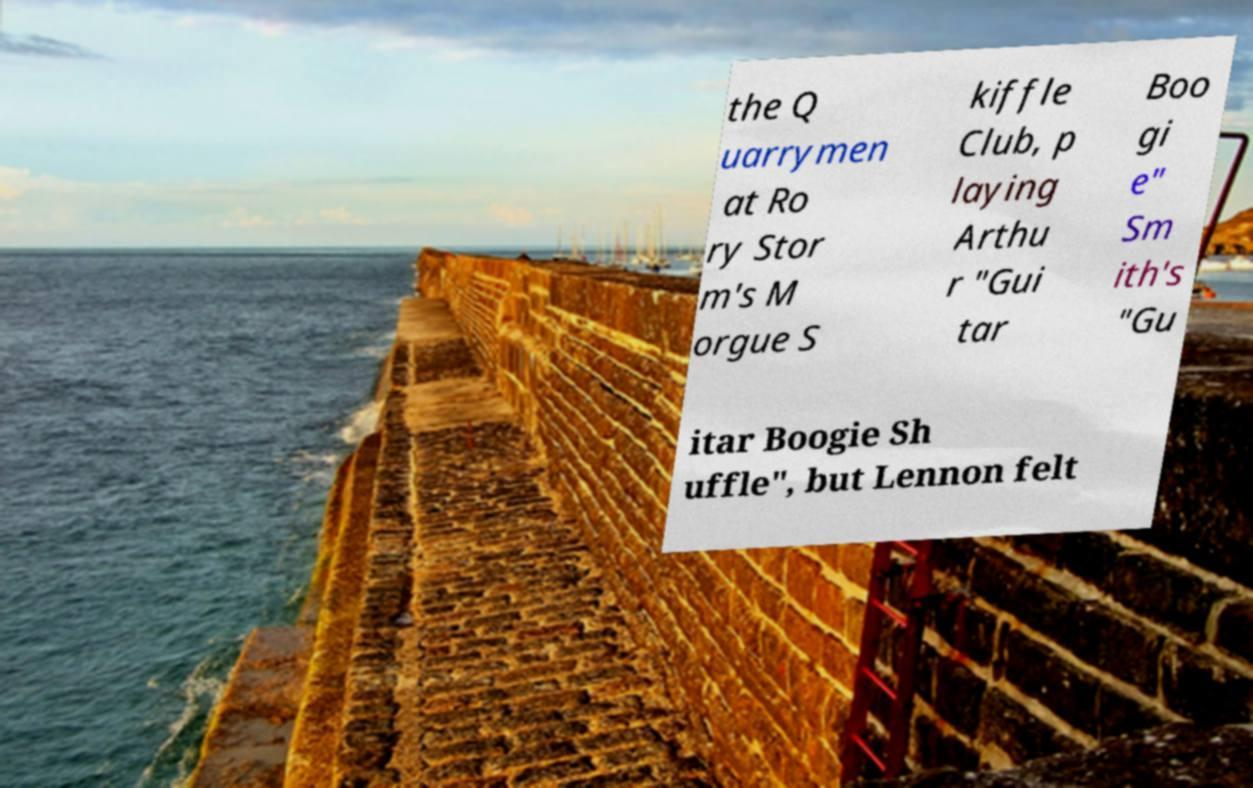Could you extract and type out the text from this image? the Q uarrymen at Ro ry Stor m's M orgue S kiffle Club, p laying Arthu r "Gui tar Boo gi e" Sm ith's "Gu itar Boogie Sh uffle", but Lennon felt 